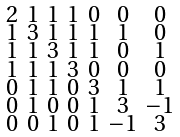Convert formula to latex. <formula><loc_0><loc_0><loc_500><loc_500>\begin{smallmatrix} 2 & 1 & 1 & 1 & 0 & 0 & 0 \\ 1 & 3 & 1 & 1 & 1 & 1 & 0 \\ 1 & 1 & 3 & 1 & 1 & 0 & 1 \\ 1 & 1 & 1 & 3 & 0 & 0 & 0 \\ 0 & 1 & 1 & 0 & 3 & 1 & 1 \\ 0 & 1 & 0 & 0 & 1 & 3 & - 1 \\ 0 & 0 & 1 & 0 & 1 & - 1 & 3 \end{smallmatrix}</formula> 